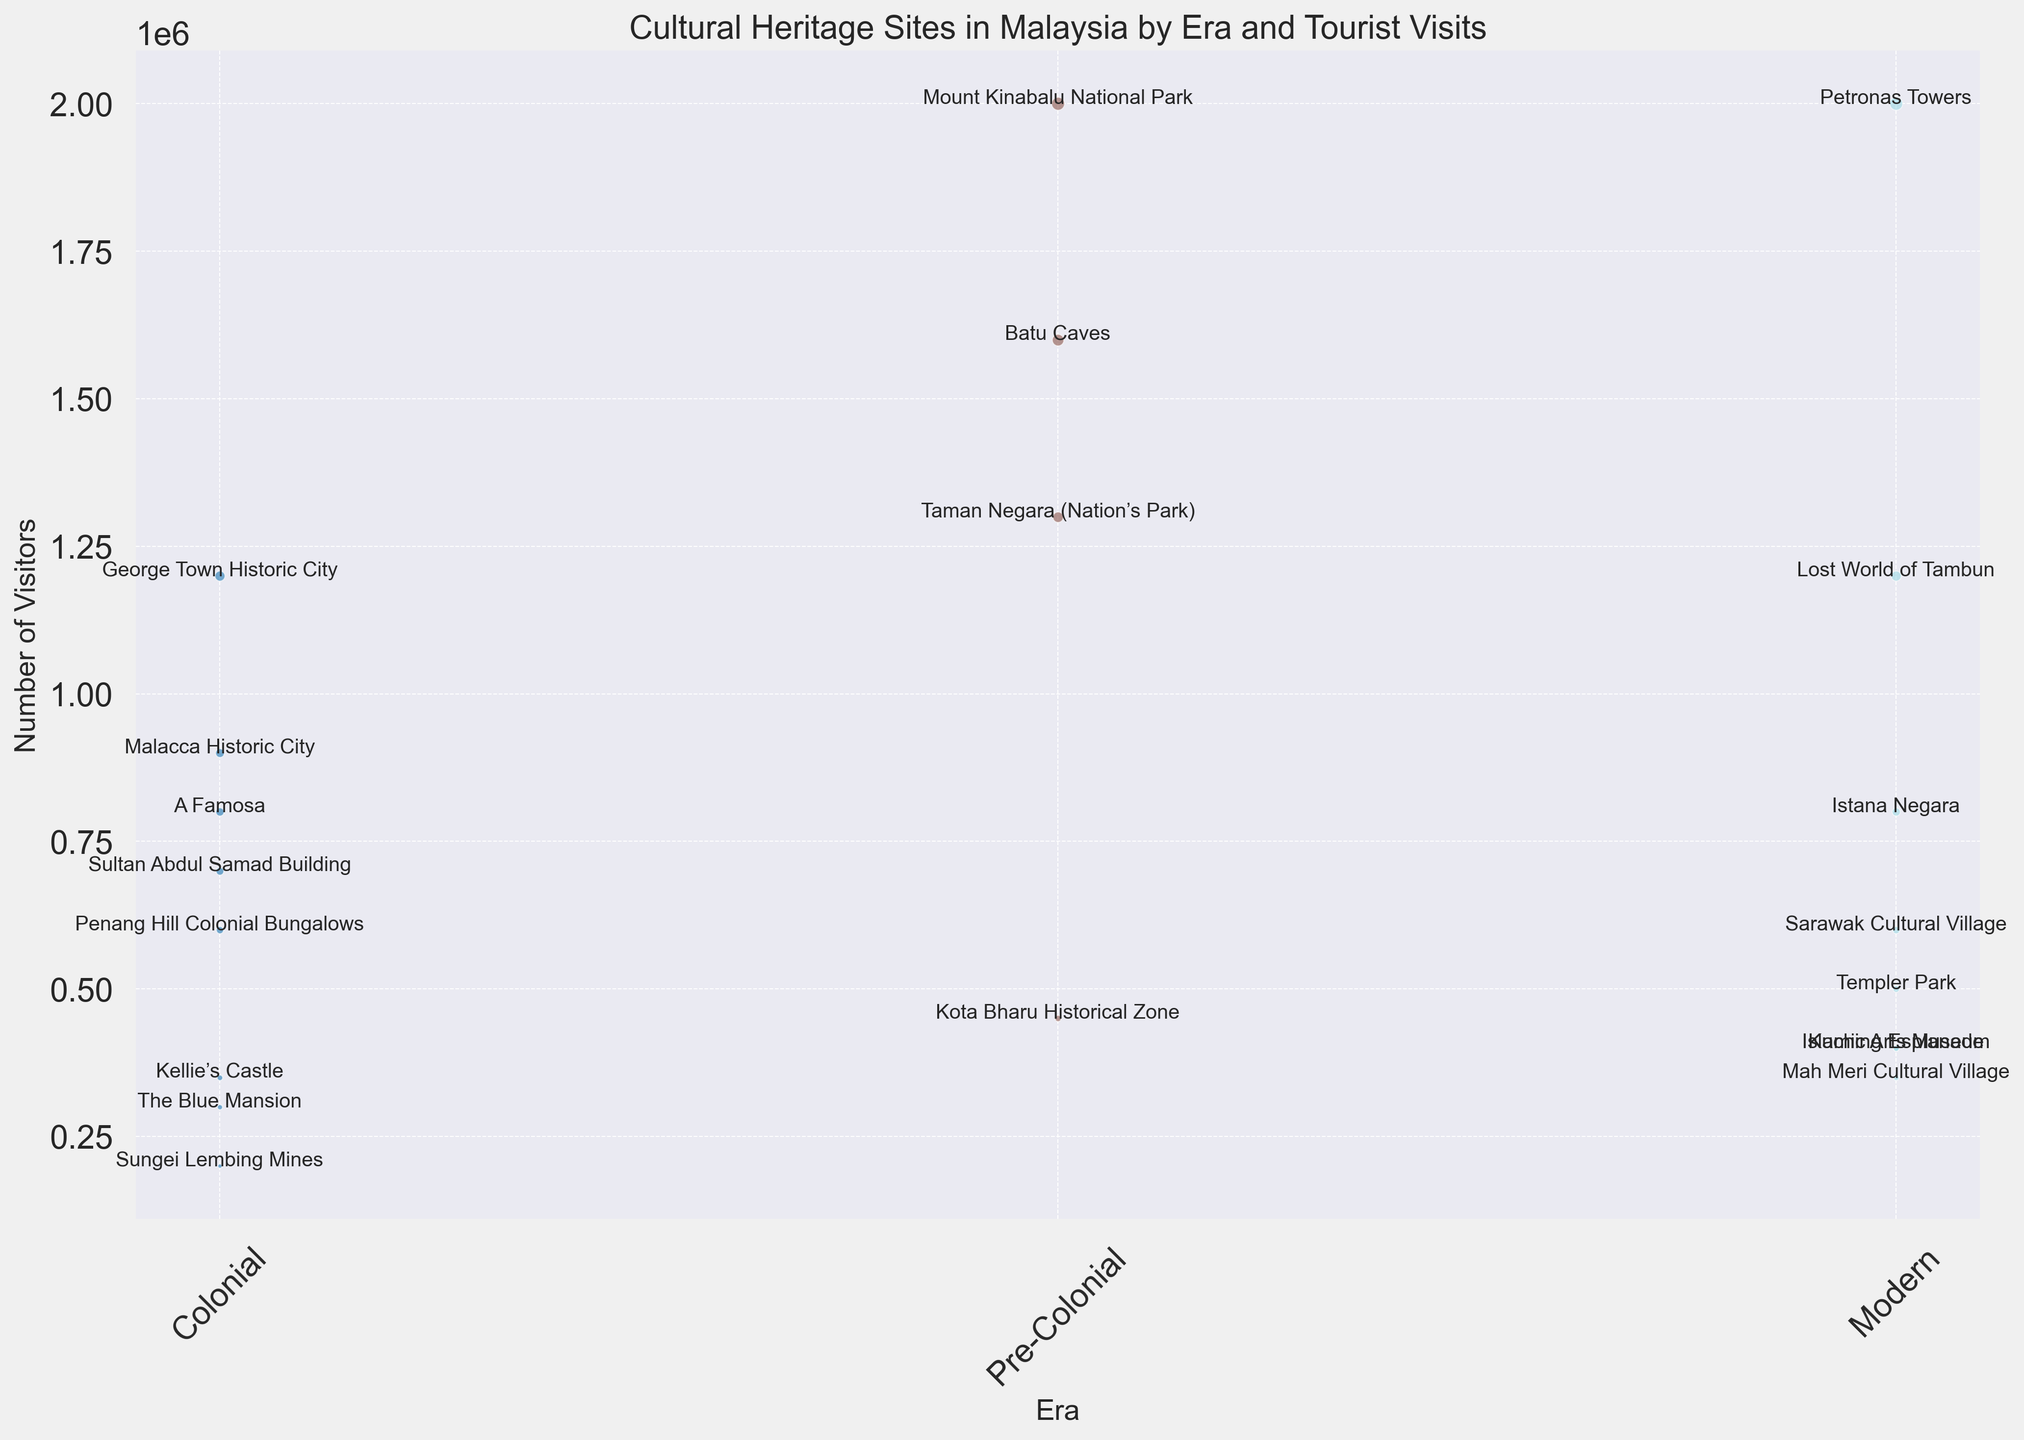Which site from the Colonial era has the highest number of visitors? The visualization shows the size of the bubbles representing the number of visitors for each site in the Colonial era. By comparing the sizes, George Town Historic City has the largest bubble among Colonial sites, indicating the highest number of visitors.
Answer: George Town Historic City How many visitors in total visit the Colonial sites? Sum the number of visitors for all Colonial sites: George Town Historic City (1,200,000), Malacca Historic City (900,000), Sultan Abdul Samad Building (700,000), Kellie’s Castle (350,000), A Famosa (800,000), Penang Hill Colonial Bungalows (600,000), The Blue Mansion (300,000), Sungei Lembing Mines (200,000). The total sum is 1,200,000 + 900,000 + 700,000 + 350,000 + 800,000 + 600,000 + 300,000 + 200,000 = 5,050,000
Answer: 5,050,000 Which era has the site with the highest number of visitors and what is that site? The visualization shows the Petronas Towers has the largest bubble among all the sites, indicating it has the highest number of visitors. This site falls under the Modern era.
Answer: Modern era, Petronas Towers Compare the total number of visitors to Pre-Colonial sites versus Modern sites. Which era sees more visitors? Sum the total visitors for Pre-Colonial and Modern sites separately: Pre-Colonial: Kota Bharu Historical Zone (450,000), Batu Caves (1,600,000), Taman Negara (1,300,000), Mount Kinabalu National Park (2,000,000). Total = 450,000 + 1,600,000 + 1,300,000 + 2,000,000 = 5,350,000. Modern: Istana Negara (800,000), Templer Park (500,000), Islamic Arts Museum (400,000), Sarawak Cultural Village (600,000), Petronas Towers (2,000,000), Kuching Esplanade (400,000), Lost World of Tambun (1,200,000), Mah Meri Cultural Village (350,000). Total = 800,000 + 500,000 + 400,000 + 600,000 + 2,000,000 + 400,000 + 1,200,000 + 350,000 = 6,250,000. Comparing these totals, Modern sites see more visitors.
Answer: Modern era What is the average number of visitors per site for the Colonial era? Sum the total visitors for Colonial sites and divide by the number of Colonial sites: 5,050,000 total visitors / 8 sites = 631,250 average visitors per site.
Answer: 631,250 Which Pre-Colonial site has the lowest number of visitors? By comparing the sizes of the bubbles representing Pre-Colonial sites, Kota Bharu Historical Zone has the smallest bubble, indicating it has the lowest number of visitors.
Answer: Kota Bharu Historical Zone Identify the color representing Modern era sites and name one site that belongs to this era. The visualization shows the Modern era sites with a specific color. Identifying this color visually (for example, if it were blue), one site that belongs to this era would be Petronas Towers.
Answer: Petronas Towers Among the listed sites, which two has exactly equal number of visitors? By comparing the sizes of the bubbles, Istana Negara and A Famosa each have 800,000 visitors, as they are represented by bubbles of the same size.
Answer: Istana Negara and A Famosa What is the difference in the number of visitors between Batu Caves and Taman Negara (Nation’s Park)? Subtract the number of visitors of Taman Negara (1,300,000) from that of Batu Caves (1,600,000): 1,600,000 - 1,300,000 = 300,000.
Answer: 300,000 Which Modern site receives the second highest number of visitors? From the visual comparison of bubble sizes for Modern era sites, the Lost World of Tambun appears to be the second largest bubble after Petronas Towers, indicating it has the second highest number of visitors.
Answer: Lost World of Tambun 